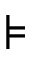<formula> <loc_0><loc_0><loc_500><loc_500>\models</formula> 